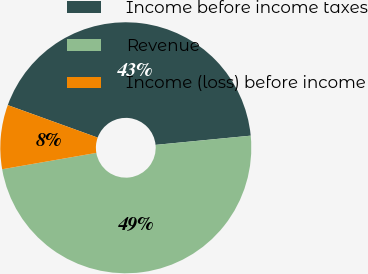<chart> <loc_0><loc_0><loc_500><loc_500><pie_chart><fcel>Income before income taxes<fcel>Revenue<fcel>Income (loss) before income<nl><fcel>42.94%<fcel>48.8%<fcel>8.26%<nl></chart> 